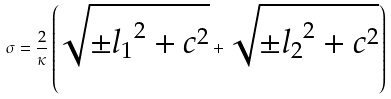Convert formula to latex. <formula><loc_0><loc_0><loc_500><loc_500>\sigma = \frac { 2 } { \kappa } \left ( { \sqrt { { \pm } { l _ { 1 } } ^ { 2 } + c ^ { 2 } } } + { \sqrt { { \pm } { l _ { 2 } } ^ { 2 } + c ^ { 2 } } } \right )</formula> 